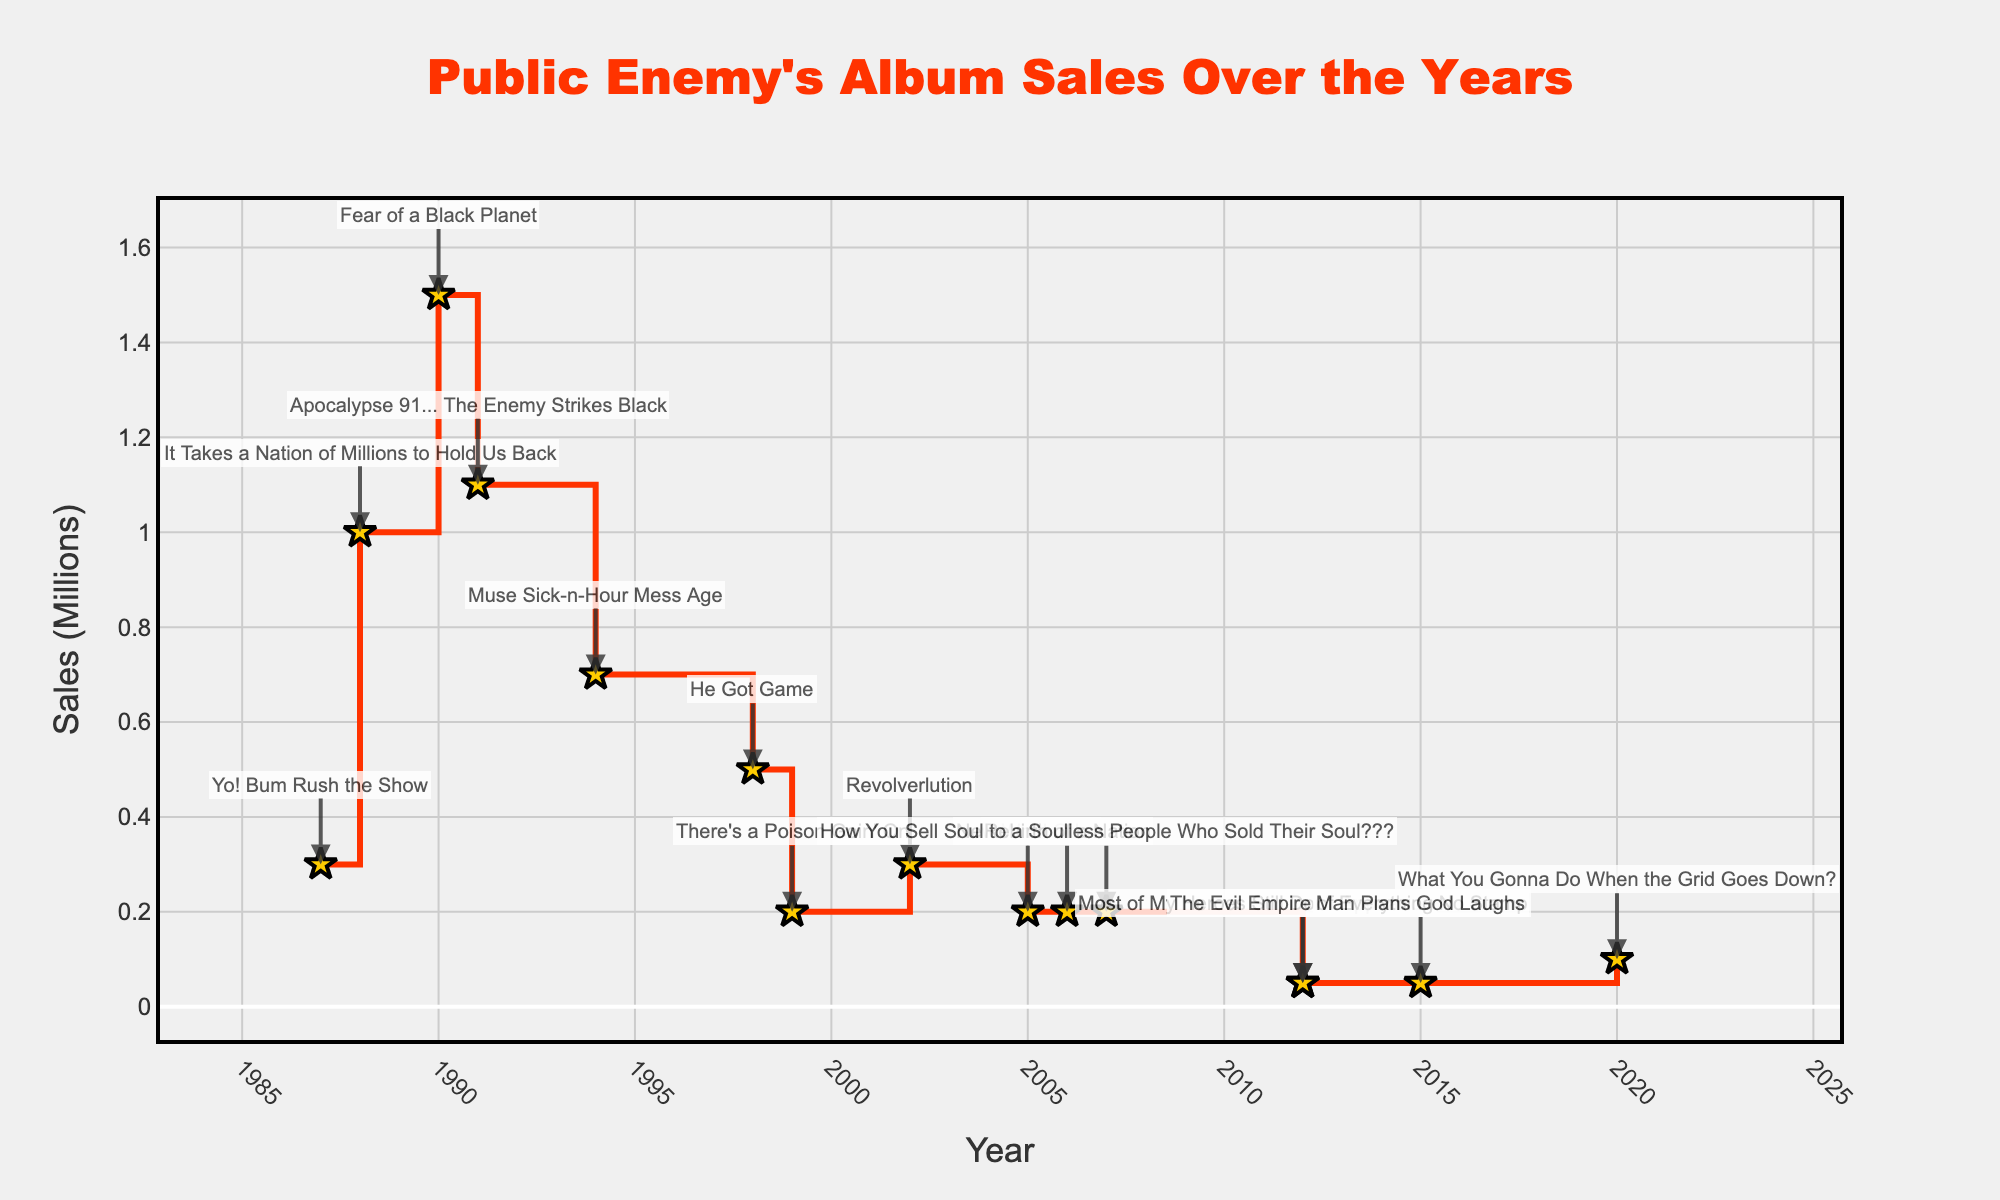What is the title of the figure? The title is prominently displayed at the top center of the figure. By looking at the title, we can identify it.
Answer: Public Enemy's Album Sales Over the Years What is the time span covered in the figure? By examining the x-axis, we can see the range of years from the first to the last tick mark.
Answer: 1987 to 2020 Which album had the highest sales? Locate the highest point on the y-axis, then refer to the annotation next to that point.
Answer: Fear of a Black Planet In which year did Public Enemy release two albums? Look for years where two annotations appear.
Answer: 2012 How much did "Apocalypse 91... The Enemy Strikes Black" sell? Find the annotation labeled with the album name and read the corresponding y-value.
Answer: 1.1 million What is the average album sales during the 1980s? Identify and sum up the sales from the 1980s (1987 and 1988), then divide by the number of albums released in that decade. Calculation: (0.3 + 1.0) / 2
Answer: 0.65 million How did the sales trend change from "Fear of a Black Planet" to "Apocalypse 91... The Enemy Strikes Black"? Examine the y-axis values from "Fear of a Black Planet" (1990) to "Apocalypse 91... The Enemy Strikes Black" (1991). Note the sales decrease.
Answer: Decreased by 0.4 million Compare the sales of the albums released in 1999 and the sales of the albums released in 2002. Which one sold more? Find the y-axis values for the albums in 1999 and 2002, compare and see which one is higher.
Answer: Revolverlution (2002) Which decade saw the most dramatic decline in album sales? Observe the slope and differences of the sales lines across decades by examining the plot segments. The most significant decline should be apparent.
Answer: 2010s How many albums sold more than 1 million copies? Identify points above 1.0 on the y-axis and count their annotations.
Answer: Three 